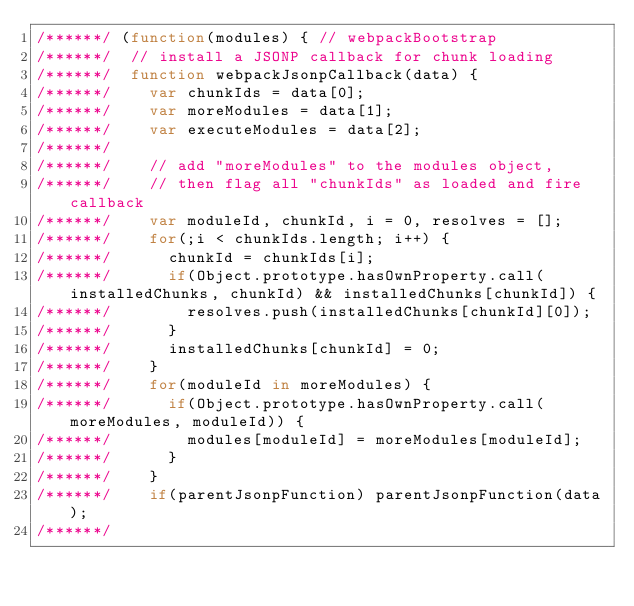<code> <loc_0><loc_0><loc_500><loc_500><_JavaScript_>/******/ (function(modules) { // webpackBootstrap
/******/ 	// install a JSONP callback for chunk loading
/******/ 	function webpackJsonpCallback(data) {
/******/ 		var chunkIds = data[0];
/******/ 		var moreModules = data[1];
/******/ 		var executeModules = data[2];
/******/
/******/ 		// add "moreModules" to the modules object,
/******/ 		// then flag all "chunkIds" as loaded and fire callback
/******/ 		var moduleId, chunkId, i = 0, resolves = [];
/******/ 		for(;i < chunkIds.length; i++) {
/******/ 			chunkId = chunkIds[i];
/******/ 			if(Object.prototype.hasOwnProperty.call(installedChunks, chunkId) && installedChunks[chunkId]) {
/******/ 				resolves.push(installedChunks[chunkId][0]);
/******/ 			}
/******/ 			installedChunks[chunkId] = 0;
/******/ 		}
/******/ 		for(moduleId in moreModules) {
/******/ 			if(Object.prototype.hasOwnProperty.call(moreModules, moduleId)) {
/******/ 				modules[moduleId] = moreModules[moduleId];
/******/ 			}
/******/ 		}
/******/ 		if(parentJsonpFunction) parentJsonpFunction(data);
/******/</code> 